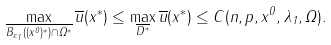<formula> <loc_0><loc_0><loc_500><loc_500>\max _ { \overline { B _ { \varepsilon _ { 1 } } ( ( x ^ { 0 } ) ^ { \ast } ) \cap \Omega ^ { \ast } } } \overline { u } ( x ^ { \ast } ) \leq \max _ { \overline { D ^ { \ast } } } \overline { u } ( x ^ { \ast } ) \leq C ( n , p , x ^ { 0 } , \lambda _ { 1 } , \Omega ) .</formula> 